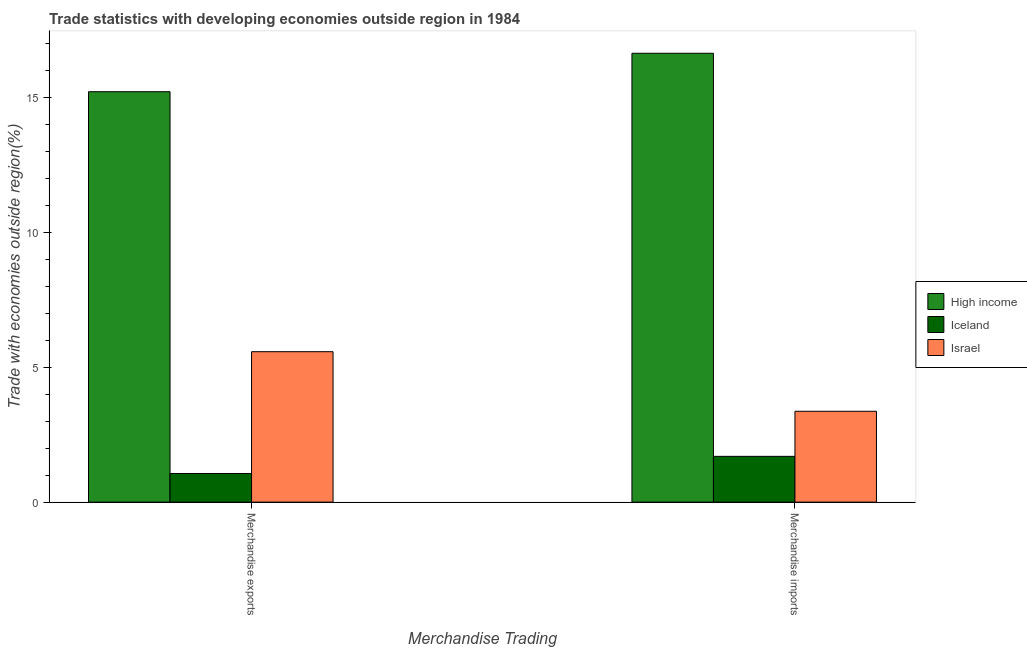Are the number of bars on each tick of the X-axis equal?
Provide a succinct answer. Yes. How many bars are there on the 2nd tick from the left?
Your response must be concise. 3. How many bars are there on the 1st tick from the right?
Your answer should be very brief. 3. What is the label of the 1st group of bars from the left?
Your response must be concise. Merchandise exports. What is the merchandise exports in Israel?
Offer a terse response. 5.58. Across all countries, what is the maximum merchandise imports?
Give a very brief answer. 16.64. Across all countries, what is the minimum merchandise exports?
Ensure brevity in your answer.  1.06. In which country was the merchandise exports maximum?
Give a very brief answer. High income. In which country was the merchandise exports minimum?
Provide a short and direct response. Iceland. What is the total merchandise exports in the graph?
Your answer should be compact. 21.86. What is the difference between the merchandise exports in Iceland and that in Israel?
Provide a short and direct response. -4.52. What is the difference between the merchandise imports in High income and the merchandise exports in Israel?
Offer a terse response. 11.06. What is the average merchandise imports per country?
Provide a short and direct response. 7.24. What is the difference between the merchandise imports and merchandise exports in Israel?
Keep it short and to the point. -2.21. What is the ratio of the merchandise exports in Israel to that in Iceland?
Ensure brevity in your answer.  5.25. What is the difference between two consecutive major ticks on the Y-axis?
Make the answer very short. 5. Are the values on the major ticks of Y-axis written in scientific E-notation?
Offer a very short reply. No. Where does the legend appear in the graph?
Your answer should be compact. Center right. How many legend labels are there?
Your response must be concise. 3. What is the title of the graph?
Your response must be concise. Trade statistics with developing economies outside region in 1984. Does "Japan" appear as one of the legend labels in the graph?
Keep it short and to the point. No. What is the label or title of the X-axis?
Your answer should be very brief. Merchandise Trading. What is the label or title of the Y-axis?
Your answer should be compact. Trade with economies outside region(%). What is the Trade with economies outside region(%) of High income in Merchandise exports?
Offer a very short reply. 15.22. What is the Trade with economies outside region(%) in Iceland in Merchandise exports?
Your answer should be very brief. 1.06. What is the Trade with economies outside region(%) in Israel in Merchandise exports?
Give a very brief answer. 5.58. What is the Trade with economies outside region(%) in High income in Merchandise imports?
Make the answer very short. 16.64. What is the Trade with economies outside region(%) in Iceland in Merchandise imports?
Your answer should be very brief. 1.7. What is the Trade with economies outside region(%) in Israel in Merchandise imports?
Your answer should be very brief. 3.37. Across all Merchandise Trading, what is the maximum Trade with economies outside region(%) of High income?
Make the answer very short. 16.64. Across all Merchandise Trading, what is the maximum Trade with economies outside region(%) of Iceland?
Your answer should be compact. 1.7. Across all Merchandise Trading, what is the maximum Trade with economies outside region(%) in Israel?
Your answer should be compact. 5.58. Across all Merchandise Trading, what is the minimum Trade with economies outside region(%) of High income?
Your answer should be compact. 15.22. Across all Merchandise Trading, what is the minimum Trade with economies outside region(%) of Iceland?
Make the answer very short. 1.06. Across all Merchandise Trading, what is the minimum Trade with economies outside region(%) in Israel?
Provide a short and direct response. 3.37. What is the total Trade with economies outside region(%) of High income in the graph?
Offer a terse response. 31.86. What is the total Trade with economies outside region(%) in Iceland in the graph?
Keep it short and to the point. 2.76. What is the total Trade with economies outside region(%) of Israel in the graph?
Keep it short and to the point. 8.95. What is the difference between the Trade with economies outside region(%) in High income in Merchandise exports and that in Merchandise imports?
Your response must be concise. -1.43. What is the difference between the Trade with economies outside region(%) of Iceland in Merchandise exports and that in Merchandise imports?
Your answer should be compact. -0.64. What is the difference between the Trade with economies outside region(%) of Israel in Merchandise exports and that in Merchandise imports?
Provide a short and direct response. 2.21. What is the difference between the Trade with economies outside region(%) of High income in Merchandise exports and the Trade with economies outside region(%) of Iceland in Merchandise imports?
Keep it short and to the point. 13.52. What is the difference between the Trade with economies outside region(%) in High income in Merchandise exports and the Trade with economies outside region(%) in Israel in Merchandise imports?
Your answer should be compact. 11.85. What is the difference between the Trade with economies outside region(%) of Iceland in Merchandise exports and the Trade with economies outside region(%) of Israel in Merchandise imports?
Make the answer very short. -2.31. What is the average Trade with economies outside region(%) of High income per Merchandise Trading?
Your response must be concise. 15.93. What is the average Trade with economies outside region(%) in Iceland per Merchandise Trading?
Make the answer very short. 1.38. What is the average Trade with economies outside region(%) of Israel per Merchandise Trading?
Make the answer very short. 4.47. What is the difference between the Trade with economies outside region(%) of High income and Trade with economies outside region(%) of Iceland in Merchandise exports?
Ensure brevity in your answer.  14.15. What is the difference between the Trade with economies outside region(%) in High income and Trade with economies outside region(%) in Israel in Merchandise exports?
Keep it short and to the point. 9.64. What is the difference between the Trade with economies outside region(%) of Iceland and Trade with economies outside region(%) of Israel in Merchandise exports?
Give a very brief answer. -4.52. What is the difference between the Trade with economies outside region(%) of High income and Trade with economies outside region(%) of Iceland in Merchandise imports?
Provide a short and direct response. 14.94. What is the difference between the Trade with economies outside region(%) of High income and Trade with economies outside region(%) of Israel in Merchandise imports?
Offer a terse response. 13.27. What is the difference between the Trade with economies outside region(%) in Iceland and Trade with economies outside region(%) in Israel in Merchandise imports?
Offer a very short reply. -1.67. What is the ratio of the Trade with economies outside region(%) of High income in Merchandise exports to that in Merchandise imports?
Provide a short and direct response. 0.91. What is the ratio of the Trade with economies outside region(%) of Iceland in Merchandise exports to that in Merchandise imports?
Give a very brief answer. 0.63. What is the ratio of the Trade with economies outside region(%) in Israel in Merchandise exports to that in Merchandise imports?
Make the answer very short. 1.66. What is the difference between the highest and the second highest Trade with economies outside region(%) of High income?
Offer a terse response. 1.43. What is the difference between the highest and the second highest Trade with economies outside region(%) in Iceland?
Offer a very short reply. 0.64. What is the difference between the highest and the second highest Trade with economies outside region(%) of Israel?
Ensure brevity in your answer.  2.21. What is the difference between the highest and the lowest Trade with economies outside region(%) of High income?
Your answer should be compact. 1.43. What is the difference between the highest and the lowest Trade with economies outside region(%) in Iceland?
Provide a succinct answer. 0.64. What is the difference between the highest and the lowest Trade with economies outside region(%) of Israel?
Your answer should be compact. 2.21. 